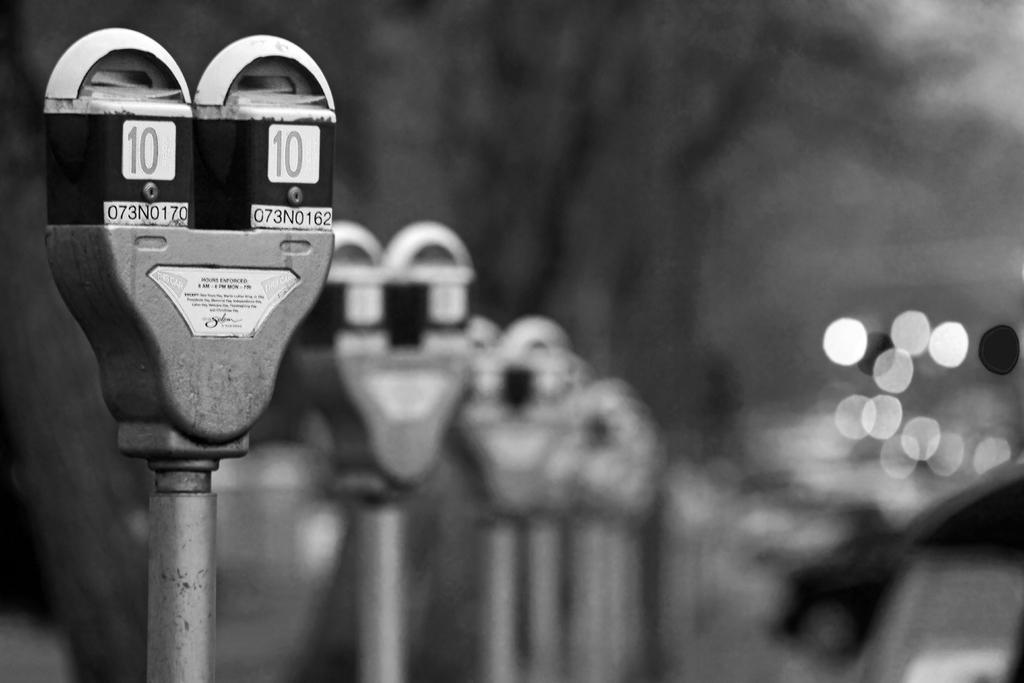<image>
Give a short and clear explanation of the subsequent image. Parking meters have the number 10 printed on them. 